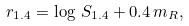<formula> <loc_0><loc_0><loc_500><loc_500>r _ { 1 . 4 } = \log \, S _ { 1 . 4 } + 0 . 4 \, m _ { R } ,</formula> 